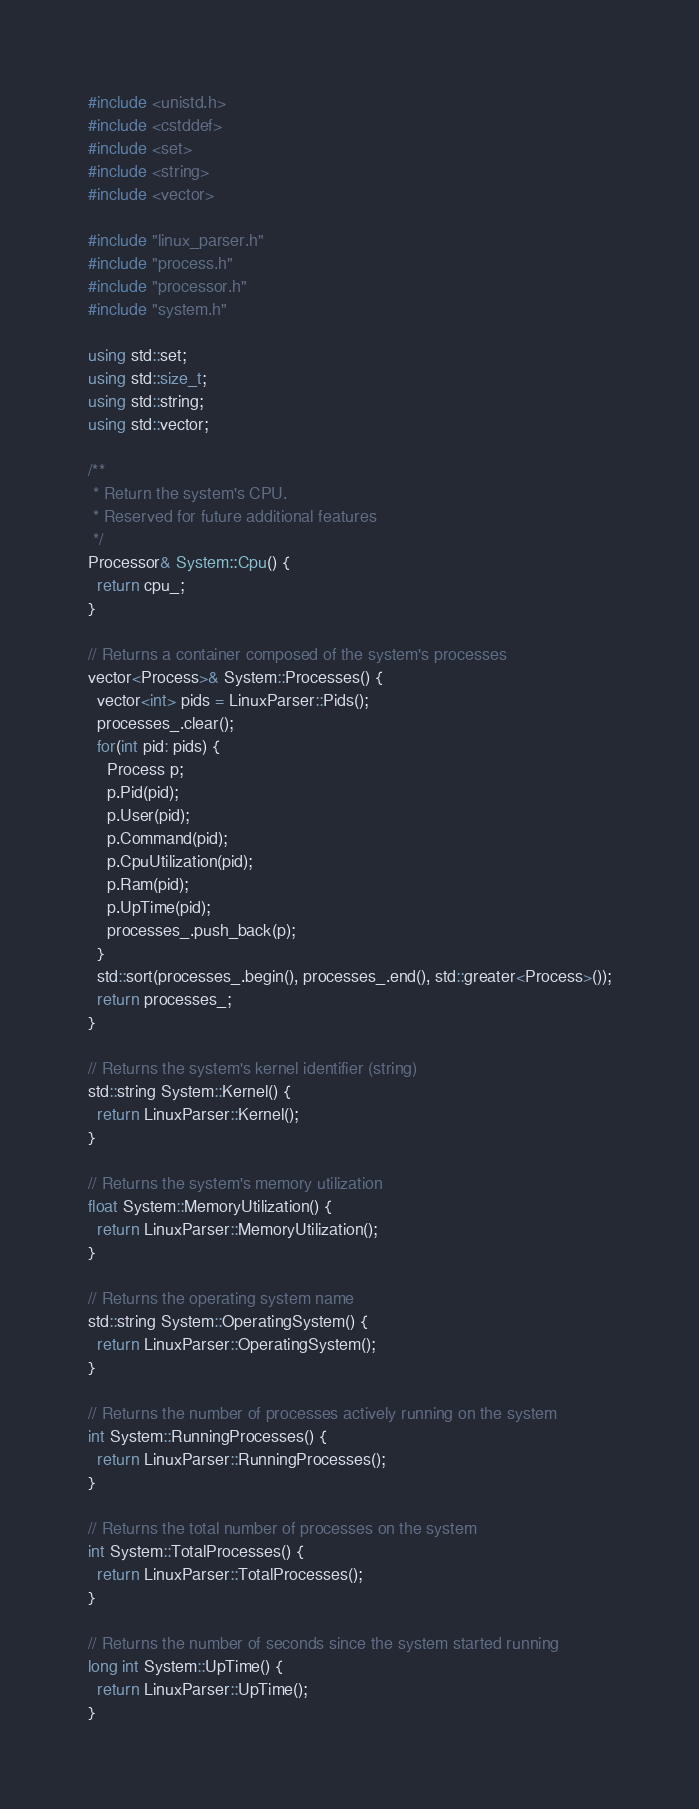Convert code to text. <code><loc_0><loc_0><loc_500><loc_500><_C++_>#include <unistd.h>
#include <cstddef>
#include <set>
#include <string>
#include <vector>

#include "linux_parser.h"
#include "process.h"
#include "processor.h"
#include "system.h"

using std::set;
using std::size_t;
using std::string;
using std::vector;

/**
 * Return the system's CPU. 
 * Reserved for future additional features
 */
Processor& System::Cpu() { 
  return cpu_; 
}

// Returns a container composed of the system's processes
vector<Process>& System::Processes() { 
  vector<int> pids = LinuxParser::Pids();
  processes_.clear();
  for(int pid: pids) {
    Process p;
    p.Pid(pid);
    p.User(pid);
    p.Command(pid);
    p.CpuUtilization(pid);
    p.Ram(pid);
    p.UpTime(pid);
    processes_.push_back(p);
  }
  std::sort(processes_.begin(), processes_.end(), std::greater<Process>());
  return processes_; 
}

// Returns the system's kernel identifier (string)
std::string System::Kernel() { 
  return LinuxParser::Kernel();
}

// Returns the system's memory utilization
float System::MemoryUtilization() { 
  return LinuxParser::MemoryUtilization(); 
}

// Returns the operating system name
std::string System::OperatingSystem() { 
  return LinuxParser::OperatingSystem(); 
}

// Returns the number of processes actively running on the system
int System::RunningProcesses() { 
  return LinuxParser::RunningProcesses();
}

// Returns the total number of processes on the system
int System::TotalProcesses() { 
  return LinuxParser::TotalProcesses(); 
}

// Returns the number of seconds since the system started running
long int System::UpTime() { 
  return LinuxParser::UpTime(); 
}</code> 